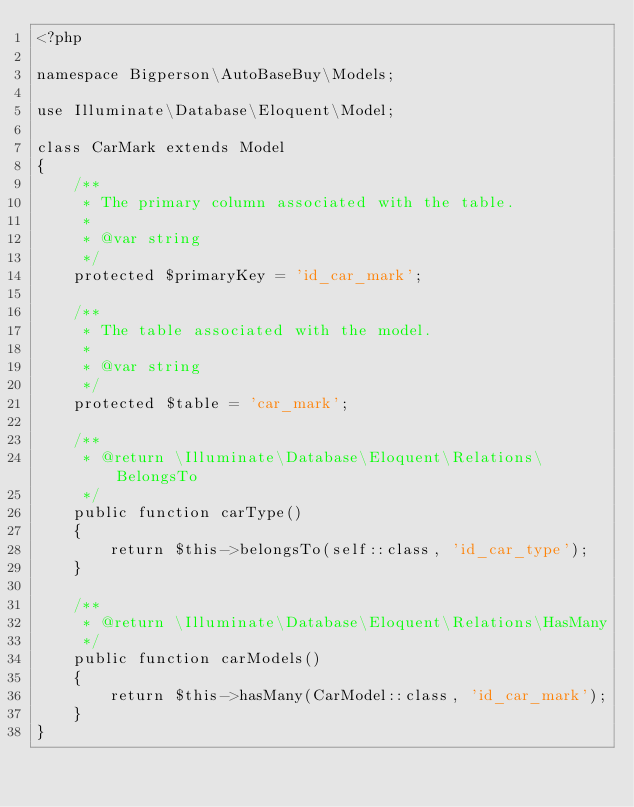<code> <loc_0><loc_0><loc_500><loc_500><_PHP_><?php

namespace Bigperson\AutoBaseBuy\Models;

use Illuminate\Database\Eloquent\Model;

class CarMark extends Model
{
    /**
     * The primary column associated with the table.
     *
     * @var string
     */
    protected $primaryKey = 'id_car_mark';

    /**
     * The table associated with the model.
     *
     * @var string
     */
    protected $table = 'car_mark';

    /**
     * @return \Illuminate\Database\Eloquent\Relations\BelongsTo
     */
    public function carType()
    {
        return $this->belongsTo(self::class, 'id_car_type');
    }

    /**
     * @return \Illuminate\Database\Eloquent\Relations\HasMany
     */
    public function carModels()
    {
        return $this->hasMany(CarModel::class, 'id_car_mark');
    }
}
</code> 